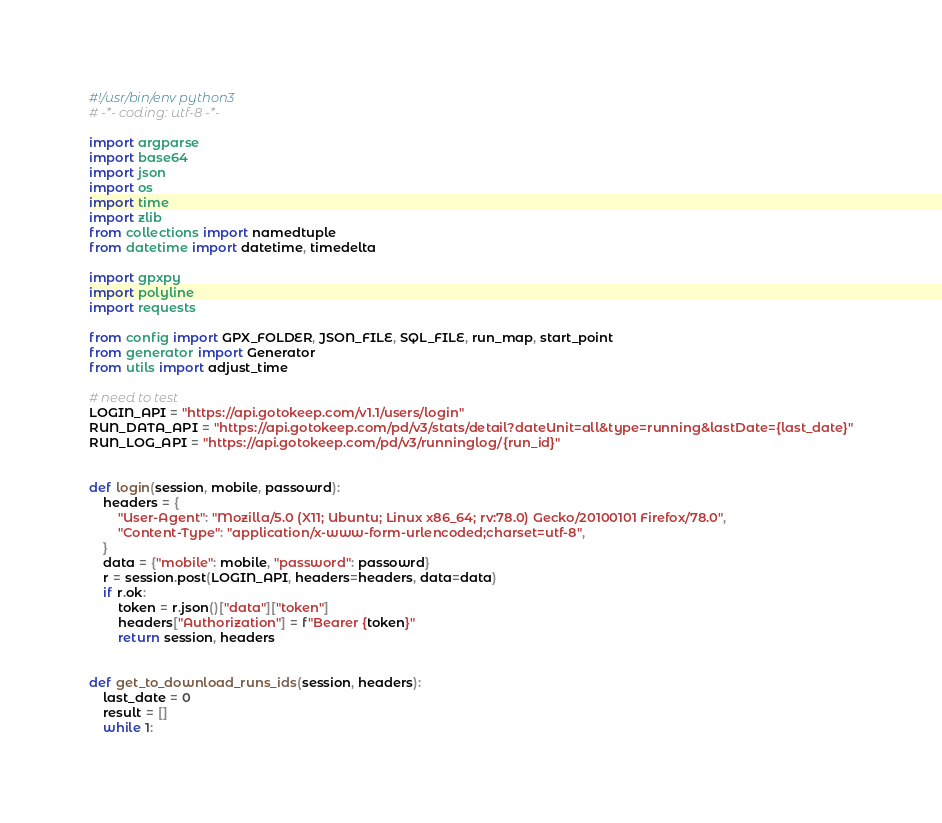<code> <loc_0><loc_0><loc_500><loc_500><_Python_>#!/usr/bin/env python3
# -*- coding: utf-8 -*-

import argparse
import base64
import json
import os
import time
import zlib
from collections import namedtuple
from datetime import datetime, timedelta

import gpxpy
import polyline
import requests

from config import GPX_FOLDER, JSON_FILE, SQL_FILE, run_map, start_point
from generator import Generator
from utils import adjust_time

# need to test
LOGIN_API = "https://api.gotokeep.com/v1.1/users/login"
RUN_DATA_API = "https://api.gotokeep.com/pd/v3/stats/detail?dateUnit=all&type=running&lastDate={last_date}"
RUN_LOG_API = "https://api.gotokeep.com/pd/v3/runninglog/{run_id}"


def login(session, mobile, passowrd):
    headers = {
        "User-Agent": "Mozilla/5.0 (X11; Ubuntu; Linux x86_64; rv:78.0) Gecko/20100101 Firefox/78.0",
        "Content-Type": "application/x-www-form-urlencoded;charset=utf-8",
    }
    data = {"mobile": mobile, "password": passowrd}
    r = session.post(LOGIN_API, headers=headers, data=data)
    if r.ok:
        token = r.json()["data"]["token"]
        headers["Authorization"] = f"Bearer {token}"
        return session, headers


def get_to_download_runs_ids(session, headers):
    last_date = 0
    result = []
    while 1:</code> 